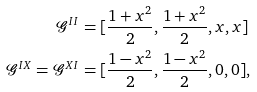Convert formula to latex. <formula><loc_0><loc_0><loc_500><loc_500>\mathcal { G } ^ { I I } & = [ \frac { 1 + x ^ { 2 } } { 2 } , \frac { 1 + x ^ { 2 } } { 2 } , x , x ] \\ \mathcal { G } ^ { I X } = \mathcal { G } ^ { X I } & = [ \frac { 1 - x ^ { 2 } } { 2 } , \frac { 1 - x ^ { 2 } } { 2 } , 0 , 0 ] ,</formula> 